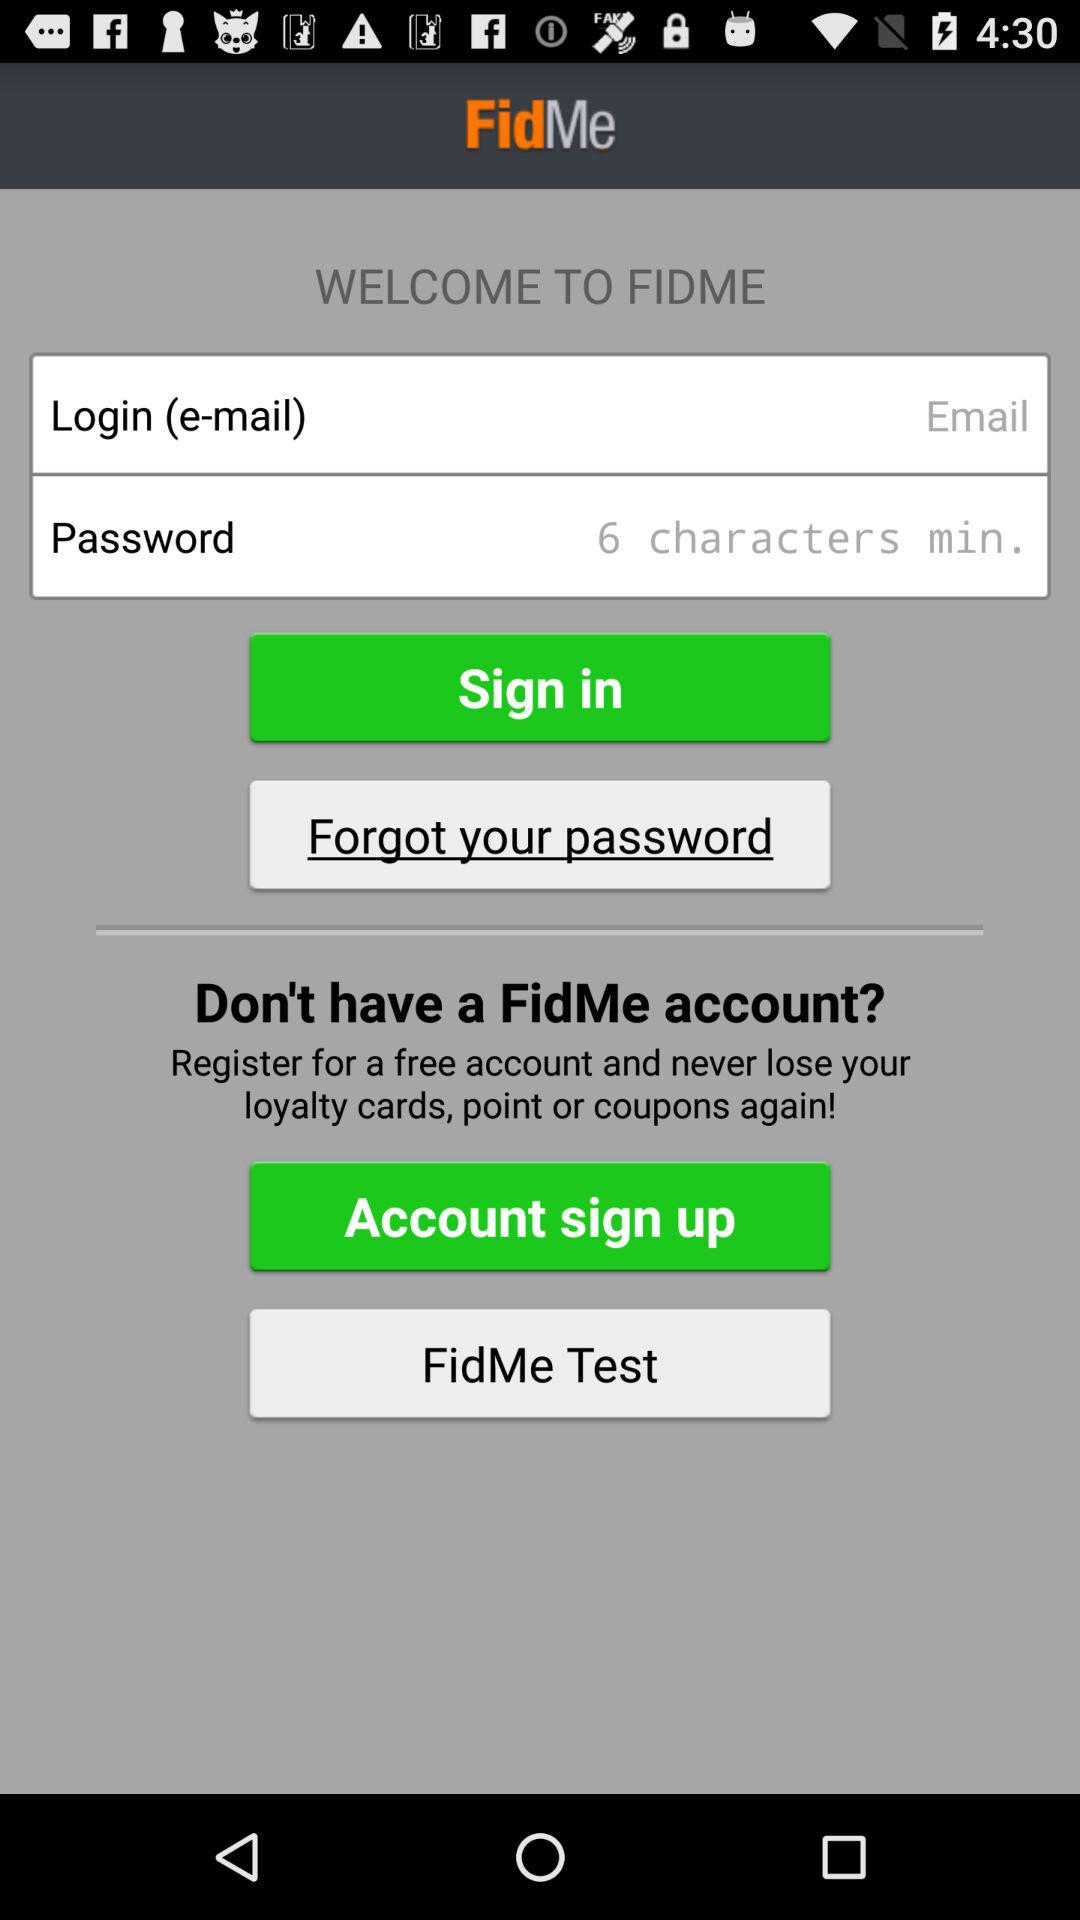How many input fields are there for logging in?
Answer the question using a single word or phrase. 2 